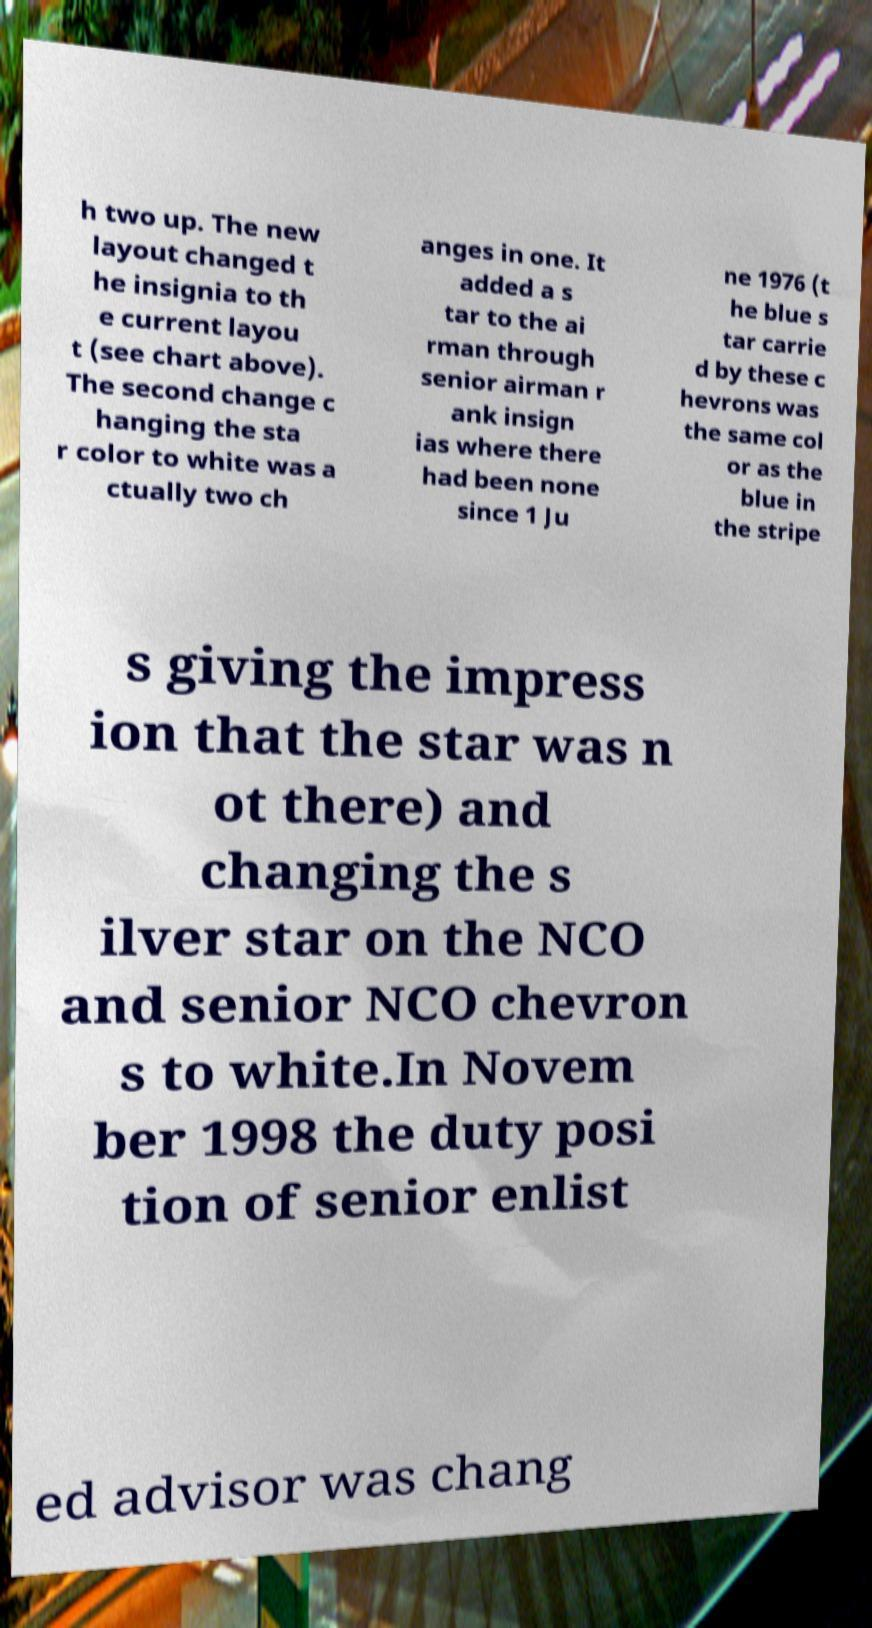Can you read and provide the text displayed in the image?This photo seems to have some interesting text. Can you extract and type it out for me? h two up. The new layout changed t he insignia to th e current layou t (see chart above). The second change c hanging the sta r color to white was a ctually two ch anges in one. It added a s tar to the ai rman through senior airman r ank insign ias where there had been none since 1 Ju ne 1976 (t he blue s tar carrie d by these c hevrons was the same col or as the blue in the stripe s giving the impress ion that the star was n ot there) and changing the s ilver star on the NCO and senior NCO chevron s to white.In Novem ber 1998 the duty posi tion of senior enlist ed advisor was chang 